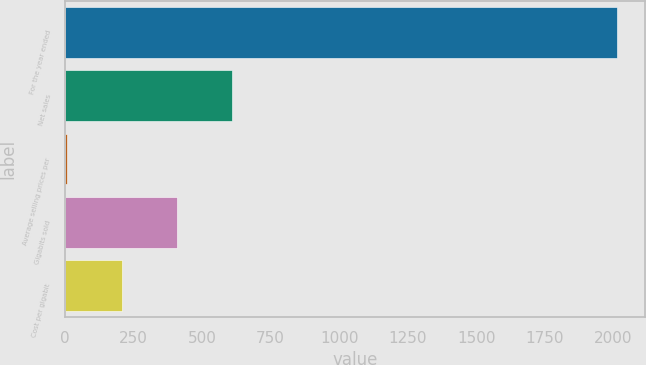Convert chart to OTSL. <chart><loc_0><loc_0><loc_500><loc_500><bar_chart><fcel>For the year ended<fcel>Net sales<fcel>Average selling prices per<fcel>Gigabits sold<fcel>Cost per gigabit<nl><fcel>2014<fcel>608.4<fcel>6<fcel>407.6<fcel>206.8<nl></chart> 